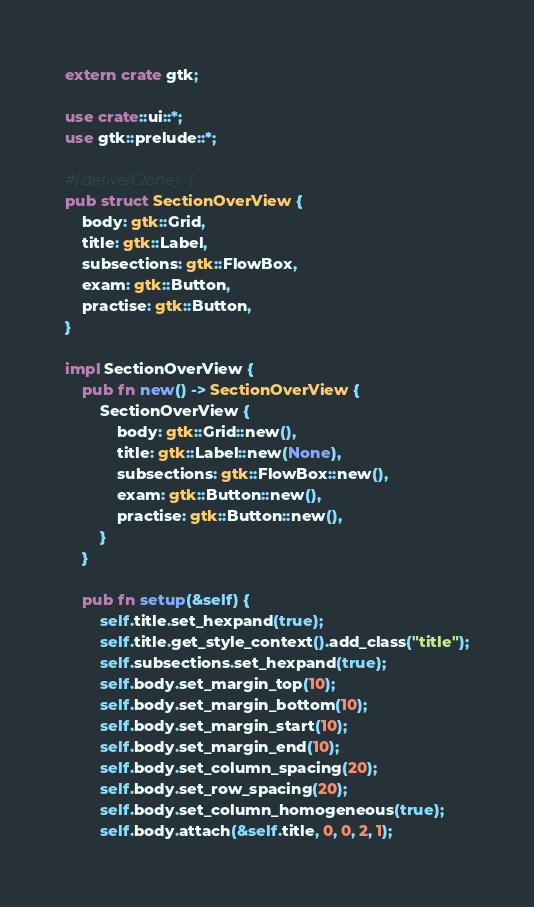Convert code to text. <code><loc_0><loc_0><loc_500><loc_500><_Rust_>extern crate gtk;

use crate::ui::*;
use gtk::prelude::*;

#[derive(Clone)]
pub struct SectionOverView {
    body: gtk::Grid,
    title: gtk::Label,
    subsections: gtk::FlowBox,
    exam: gtk::Button,
    practise: gtk::Button,
}

impl SectionOverView {
    pub fn new() -> SectionOverView {
        SectionOverView {
            body: gtk::Grid::new(),
            title: gtk::Label::new(None),
            subsections: gtk::FlowBox::new(),
            exam: gtk::Button::new(),
            practise: gtk::Button::new(),
        }
    }

    pub fn setup(&self) {
        self.title.set_hexpand(true);
        self.title.get_style_context().add_class("title");
        self.subsections.set_hexpand(true);
        self.body.set_margin_top(10);
        self.body.set_margin_bottom(10);
        self.body.set_margin_start(10);
        self.body.set_margin_end(10);
        self.body.set_column_spacing(20);
        self.body.set_row_spacing(20);
        self.body.set_column_homogeneous(true);
        self.body.attach(&self.title, 0, 0, 2, 1);</code> 